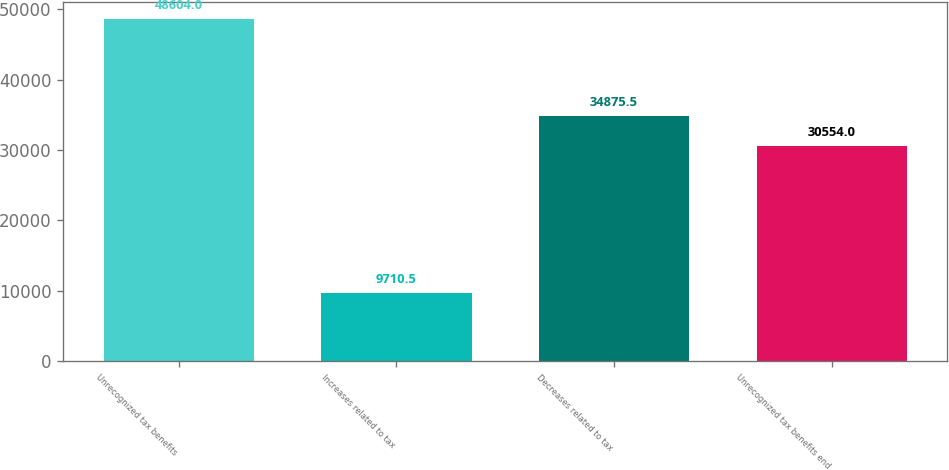Convert chart. <chart><loc_0><loc_0><loc_500><loc_500><bar_chart><fcel>Unrecognized tax benefits<fcel>Increases related to tax<fcel>Decreases related to tax<fcel>Unrecognized tax benefits end<nl><fcel>48604<fcel>9710.5<fcel>34875.5<fcel>30554<nl></chart> 